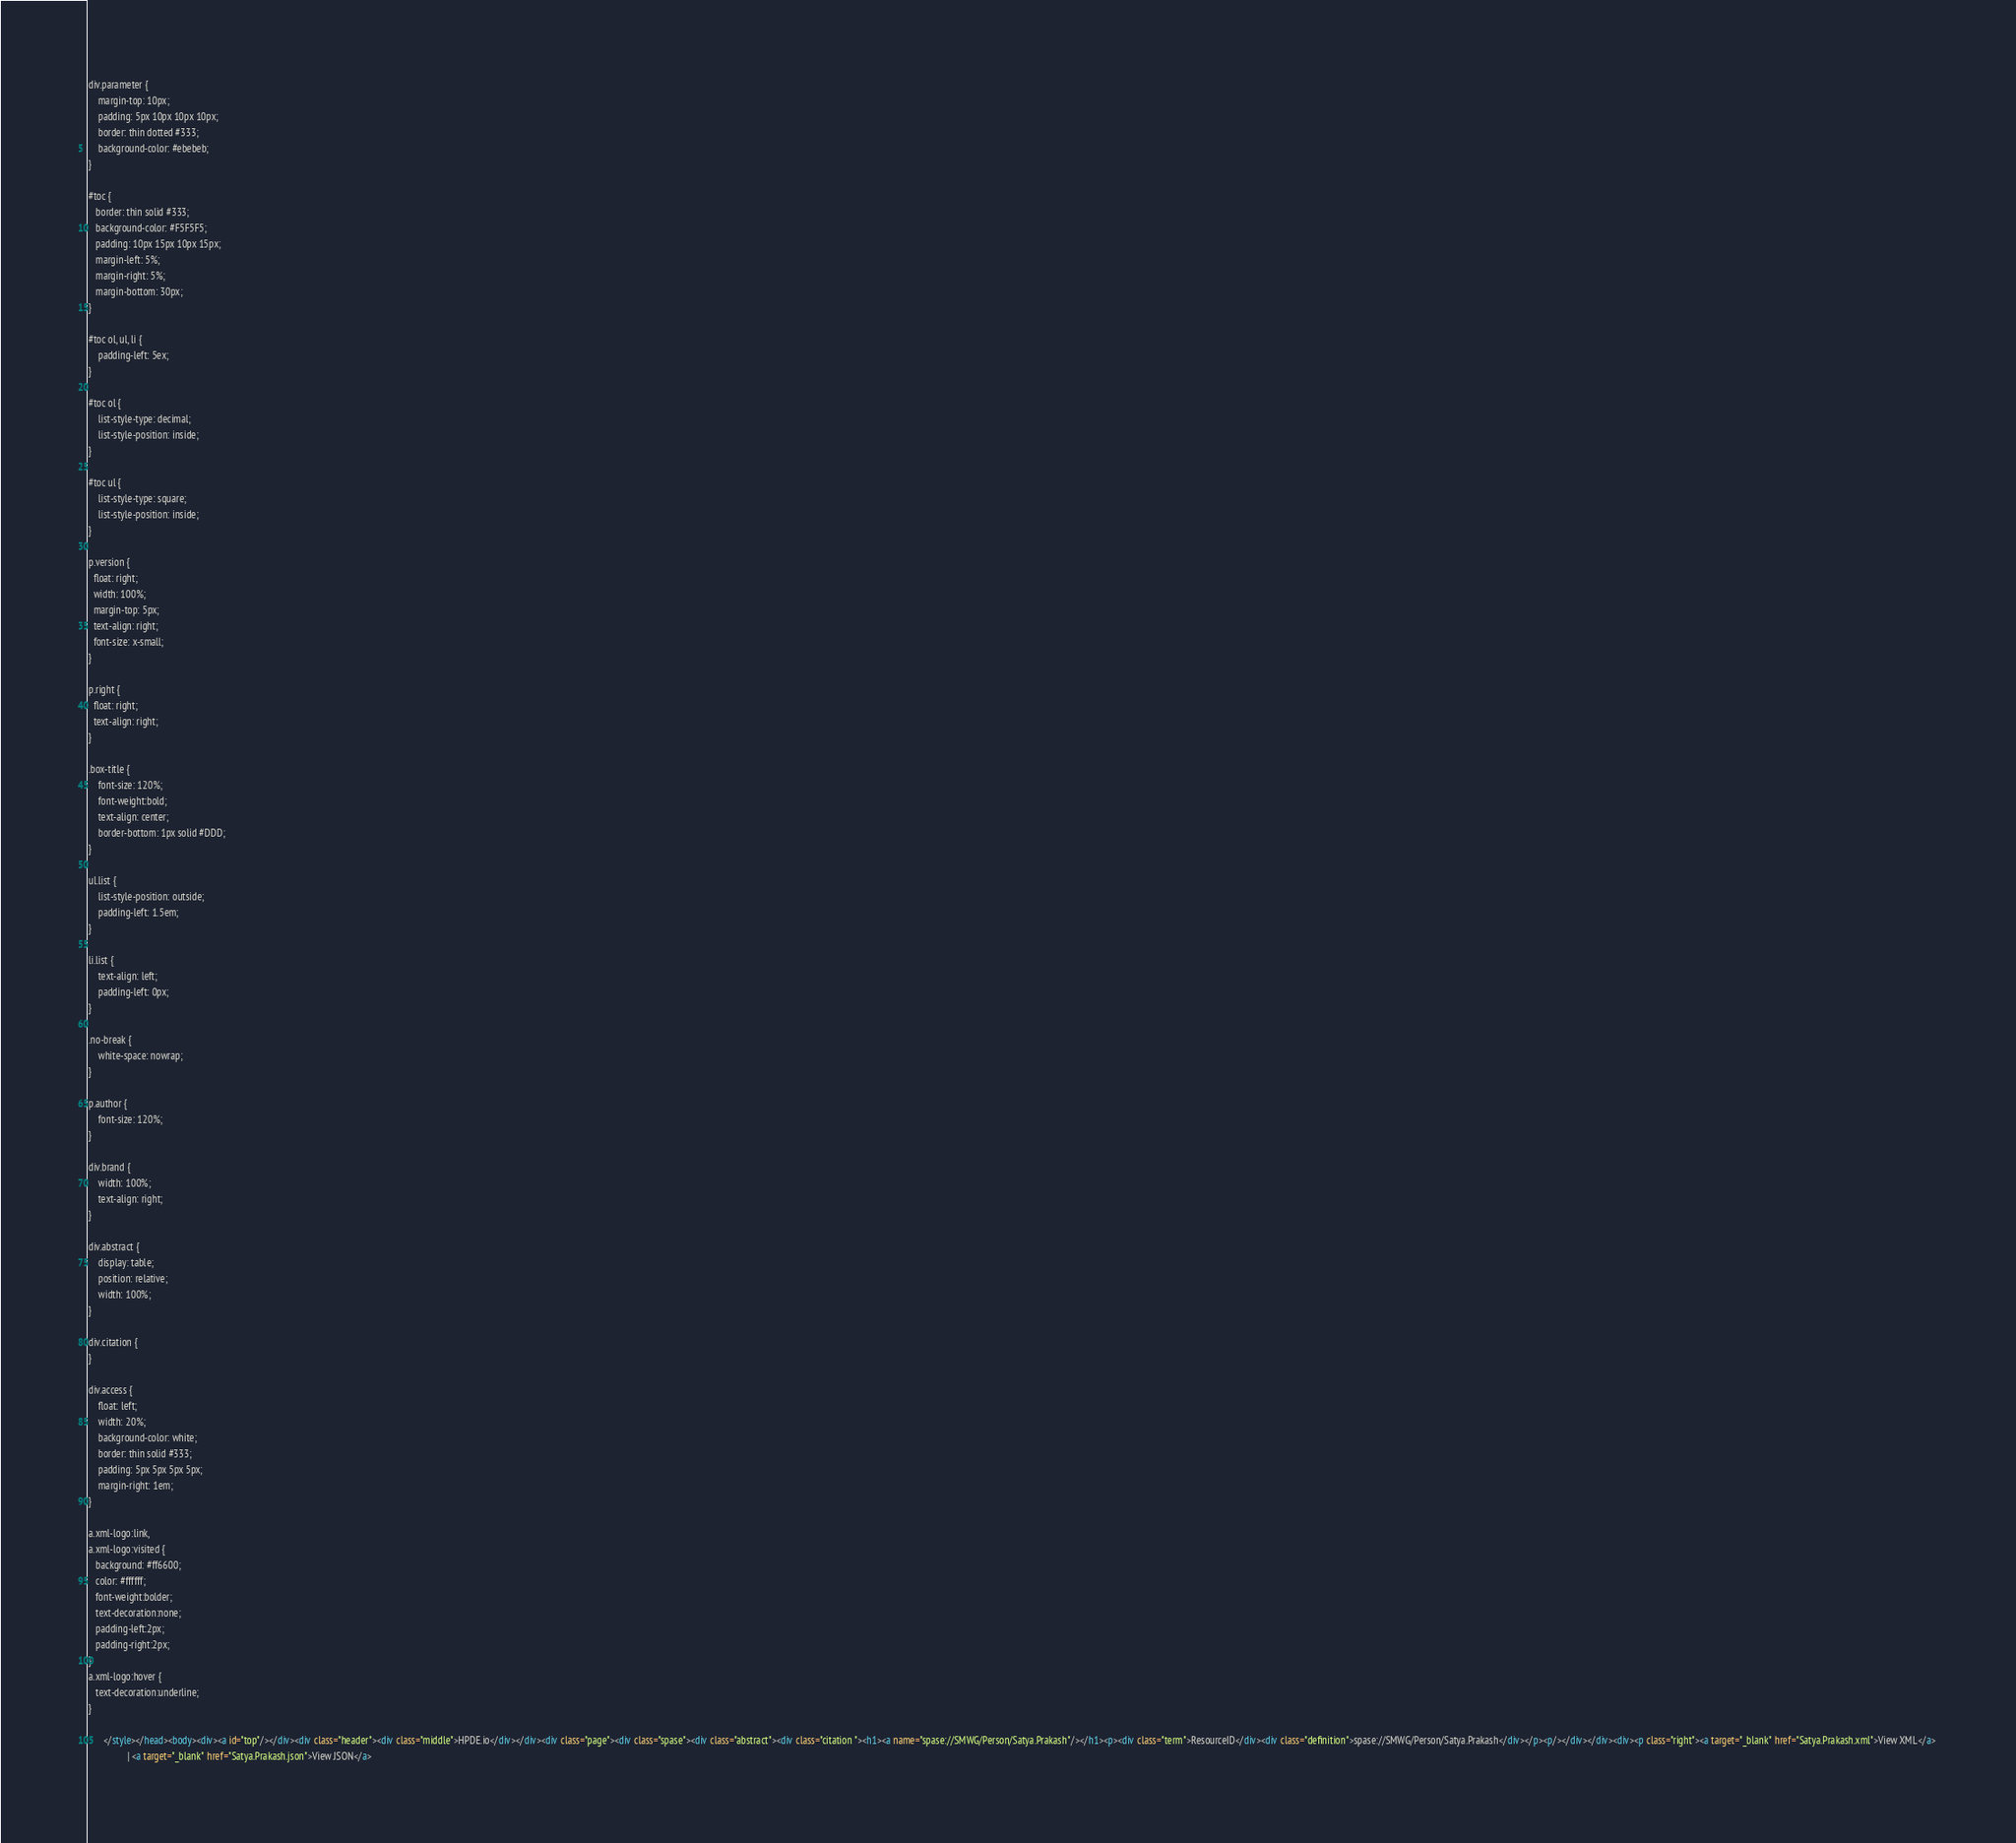Convert code to text. <code><loc_0><loc_0><loc_500><loc_500><_HTML_>div.parameter {
	margin-top: 10px;
	padding: 5px 10px 10px 10px;
	border: thin dotted #333;
	background-color: #ebebeb;
}

#toc {
   border: thin solid #333;
   background-color: #F5F5F5; 
   padding: 10px 15px 10px 15px;
   margin-left: 5%;
   margin-right: 5%;
   margin-bottom: 30px;
}

#toc ol, ul, li {
	padding-left: 5ex;
}

#toc ol {
	list-style-type: decimal;
	list-style-position: inside; 
}

#toc ul {
	list-style-type: square;
	list-style-position: inside; 
}

p.version {
  float: right;
  width: 100%;
  margin-top: 5px;
  text-align: right;
  font-size: x-small;
}

p.right {
  float: right;
  text-align: right;
}

.box-title {
	font-size: 120%;
	font-weight:bold;
	text-align: center;
	border-bottom: 1px solid #DDD;
}

ul.list {
	list-style-position: outside;
	padding-left: 1.5em;
}

li.list {
	text-align: left;
	padding-left: 0px;
}

.no-break {
	white-space: nowrap;
}

p.author {
	font-size: 120%;
}

div.brand {
	width: 100%;
	text-align: right;
}

div.abstract {
	display: table;
	position: relative;
	width: 100%;
}

div.citation {
}

div.access {
	float: left;
	width: 20%;
	background-color: white;
	border: thin solid #333;
	padding: 5px 5px 5px 5px;
	margin-right: 1em;
}

a.xml-logo:link,
a.xml-logo:visited {
   background: #ff6600;
   color: #ffffff;
   font-weight:bolder; 
   text-decoration:none; 
   padding-left:2px;
   padding-right:2px;
}
a.xml-logo:hover {
   text-decoration:underline; 
}

	  </style></head><body><div><a id="top"/></div><div class="header"><div class="middle">HPDE.io</div></div><div class="page"><div class="spase"><div class="abstract"><div class="citation "><h1><a name="spase://SMWG/Person/Satya.Prakash"/></h1><p><div class="term">ResourceID</div><div class="definition">spase://SMWG/Person/Satya.Prakash</div></p><p/></div></div><div><p class="right"><a target="_blank" href="Satya.Prakash.xml">View XML</a> 
				| <a target="_blank" href="Satya.Prakash.json">View JSON</a> </code> 